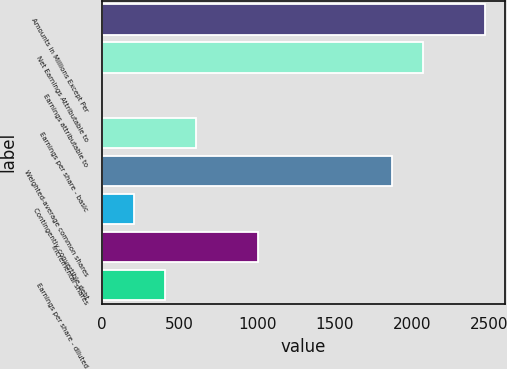Convert chart to OTSL. <chart><loc_0><loc_0><loc_500><loc_500><bar_chart><fcel>Amounts in Millions Except Per<fcel>Net Earnings Attributable to<fcel>Earnings attributable to<fcel>Earnings per share - basic<fcel>Weighted-average common shares<fcel>Contingently convertible debt<fcel>Incremental shares<fcel>Earnings per share - diluted<nl><fcel>2474.4<fcel>2072.2<fcel>1<fcel>604.3<fcel>1871.1<fcel>202.1<fcel>1006.5<fcel>403.2<nl></chart> 